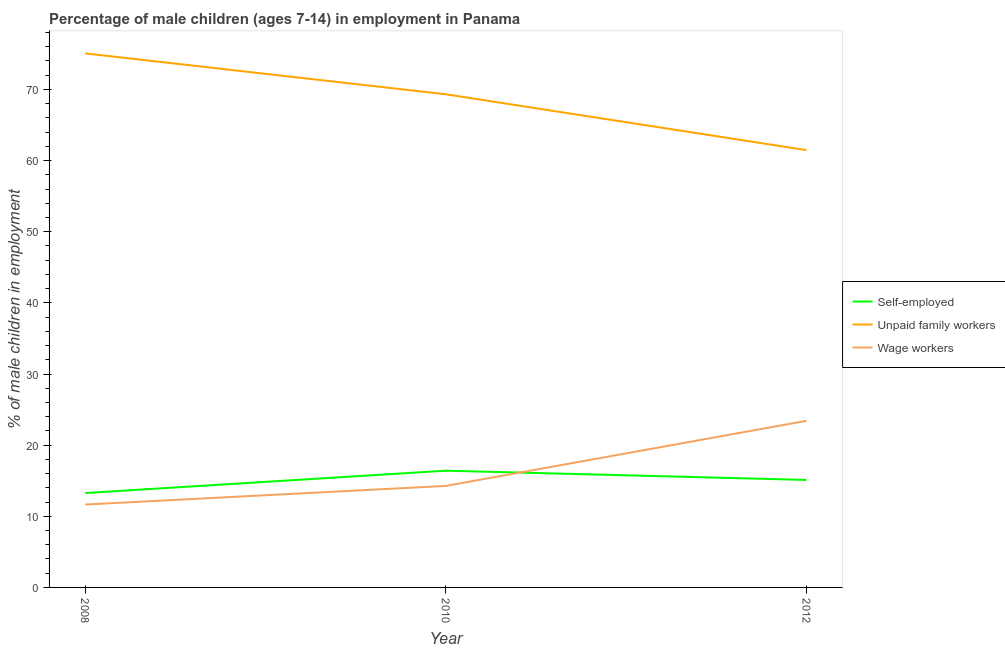Does the line corresponding to percentage of children employed as wage workers intersect with the line corresponding to percentage of self employed children?
Your answer should be compact. Yes. What is the percentage of children employed as unpaid family workers in 2010?
Offer a terse response. 69.32. Across all years, what is the maximum percentage of self employed children?
Your answer should be very brief. 16.41. Across all years, what is the minimum percentage of self employed children?
Your answer should be compact. 13.27. What is the total percentage of self employed children in the graph?
Your answer should be compact. 44.79. What is the difference between the percentage of children employed as unpaid family workers in 2010 and that in 2012?
Make the answer very short. 7.85. What is the difference between the percentage of children employed as wage workers in 2008 and the percentage of children employed as unpaid family workers in 2012?
Your answer should be compact. -49.82. What is the average percentage of children employed as wage workers per year?
Your answer should be compact. 16.45. In the year 2008, what is the difference between the percentage of children employed as unpaid family workers and percentage of self employed children?
Offer a terse response. 61.8. In how many years, is the percentage of children employed as wage workers greater than 18 %?
Offer a very short reply. 1. What is the ratio of the percentage of self employed children in 2010 to that in 2012?
Your response must be concise. 1.09. Is the percentage of self employed children in 2008 less than that in 2010?
Your answer should be compact. Yes. What is the difference between the highest and the second highest percentage of self employed children?
Make the answer very short. 1.3. What is the difference between the highest and the lowest percentage of children employed as wage workers?
Offer a very short reply. 11.77. Does the percentage of children employed as unpaid family workers monotonically increase over the years?
Your answer should be compact. No. Is the percentage of children employed as wage workers strictly greater than the percentage of self employed children over the years?
Provide a short and direct response. No. How many years are there in the graph?
Offer a very short reply. 3. What is the difference between two consecutive major ticks on the Y-axis?
Your answer should be very brief. 10. Does the graph contain any zero values?
Offer a very short reply. No. How many legend labels are there?
Give a very brief answer. 3. How are the legend labels stacked?
Keep it short and to the point. Vertical. What is the title of the graph?
Your answer should be very brief. Percentage of male children (ages 7-14) in employment in Panama. What is the label or title of the Y-axis?
Your response must be concise. % of male children in employment. What is the % of male children in employment in Self-employed in 2008?
Offer a terse response. 13.27. What is the % of male children in employment in Unpaid family workers in 2008?
Give a very brief answer. 75.07. What is the % of male children in employment of Wage workers in 2008?
Offer a terse response. 11.65. What is the % of male children in employment in Self-employed in 2010?
Provide a short and direct response. 16.41. What is the % of male children in employment in Unpaid family workers in 2010?
Provide a short and direct response. 69.32. What is the % of male children in employment of Wage workers in 2010?
Ensure brevity in your answer.  14.27. What is the % of male children in employment of Self-employed in 2012?
Your response must be concise. 15.11. What is the % of male children in employment of Unpaid family workers in 2012?
Provide a succinct answer. 61.47. What is the % of male children in employment of Wage workers in 2012?
Provide a short and direct response. 23.42. Across all years, what is the maximum % of male children in employment of Self-employed?
Offer a terse response. 16.41. Across all years, what is the maximum % of male children in employment of Unpaid family workers?
Keep it short and to the point. 75.07. Across all years, what is the maximum % of male children in employment in Wage workers?
Give a very brief answer. 23.42. Across all years, what is the minimum % of male children in employment in Self-employed?
Your answer should be compact. 13.27. Across all years, what is the minimum % of male children in employment in Unpaid family workers?
Your response must be concise. 61.47. Across all years, what is the minimum % of male children in employment in Wage workers?
Ensure brevity in your answer.  11.65. What is the total % of male children in employment in Self-employed in the graph?
Your response must be concise. 44.79. What is the total % of male children in employment of Unpaid family workers in the graph?
Make the answer very short. 205.86. What is the total % of male children in employment in Wage workers in the graph?
Provide a succinct answer. 49.34. What is the difference between the % of male children in employment of Self-employed in 2008 and that in 2010?
Give a very brief answer. -3.14. What is the difference between the % of male children in employment of Unpaid family workers in 2008 and that in 2010?
Keep it short and to the point. 5.75. What is the difference between the % of male children in employment of Wage workers in 2008 and that in 2010?
Your answer should be compact. -2.62. What is the difference between the % of male children in employment in Self-employed in 2008 and that in 2012?
Offer a very short reply. -1.84. What is the difference between the % of male children in employment of Unpaid family workers in 2008 and that in 2012?
Offer a very short reply. 13.6. What is the difference between the % of male children in employment of Wage workers in 2008 and that in 2012?
Your answer should be very brief. -11.77. What is the difference between the % of male children in employment in Self-employed in 2010 and that in 2012?
Offer a terse response. 1.3. What is the difference between the % of male children in employment of Unpaid family workers in 2010 and that in 2012?
Make the answer very short. 7.85. What is the difference between the % of male children in employment in Wage workers in 2010 and that in 2012?
Keep it short and to the point. -9.15. What is the difference between the % of male children in employment in Self-employed in 2008 and the % of male children in employment in Unpaid family workers in 2010?
Your response must be concise. -56.05. What is the difference between the % of male children in employment in Self-employed in 2008 and the % of male children in employment in Wage workers in 2010?
Offer a terse response. -1. What is the difference between the % of male children in employment of Unpaid family workers in 2008 and the % of male children in employment of Wage workers in 2010?
Provide a succinct answer. 60.8. What is the difference between the % of male children in employment of Self-employed in 2008 and the % of male children in employment of Unpaid family workers in 2012?
Provide a succinct answer. -48.2. What is the difference between the % of male children in employment of Self-employed in 2008 and the % of male children in employment of Wage workers in 2012?
Your response must be concise. -10.15. What is the difference between the % of male children in employment of Unpaid family workers in 2008 and the % of male children in employment of Wage workers in 2012?
Provide a short and direct response. 51.65. What is the difference between the % of male children in employment of Self-employed in 2010 and the % of male children in employment of Unpaid family workers in 2012?
Your answer should be compact. -45.06. What is the difference between the % of male children in employment of Self-employed in 2010 and the % of male children in employment of Wage workers in 2012?
Provide a succinct answer. -7.01. What is the difference between the % of male children in employment in Unpaid family workers in 2010 and the % of male children in employment in Wage workers in 2012?
Ensure brevity in your answer.  45.9. What is the average % of male children in employment of Self-employed per year?
Your response must be concise. 14.93. What is the average % of male children in employment in Unpaid family workers per year?
Your answer should be compact. 68.62. What is the average % of male children in employment in Wage workers per year?
Offer a terse response. 16.45. In the year 2008, what is the difference between the % of male children in employment in Self-employed and % of male children in employment in Unpaid family workers?
Your answer should be very brief. -61.8. In the year 2008, what is the difference between the % of male children in employment in Self-employed and % of male children in employment in Wage workers?
Give a very brief answer. 1.62. In the year 2008, what is the difference between the % of male children in employment of Unpaid family workers and % of male children in employment of Wage workers?
Offer a very short reply. 63.42. In the year 2010, what is the difference between the % of male children in employment in Self-employed and % of male children in employment in Unpaid family workers?
Make the answer very short. -52.91. In the year 2010, what is the difference between the % of male children in employment in Self-employed and % of male children in employment in Wage workers?
Offer a terse response. 2.14. In the year 2010, what is the difference between the % of male children in employment of Unpaid family workers and % of male children in employment of Wage workers?
Your answer should be very brief. 55.05. In the year 2012, what is the difference between the % of male children in employment in Self-employed and % of male children in employment in Unpaid family workers?
Provide a succinct answer. -46.36. In the year 2012, what is the difference between the % of male children in employment of Self-employed and % of male children in employment of Wage workers?
Offer a terse response. -8.31. In the year 2012, what is the difference between the % of male children in employment of Unpaid family workers and % of male children in employment of Wage workers?
Your answer should be very brief. 38.05. What is the ratio of the % of male children in employment in Self-employed in 2008 to that in 2010?
Provide a short and direct response. 0.81. What is the ratio of the % of male children in employment of Unpaid family workers in 2008 to that in 2010?
Your answer should be compact. 1.08. What is the ratio of the % of male children in employment in Wage workers in 2008 to that in 2010?
Keep it short and to the point. 0.82. What is the ratio of the % of male children in employment of Self-employed in 2008 to that in 2012?
Your response must be concise. 0.88. What is the ratio of the % of male children in employment in Unpaid family workers in 2008 to that in 2012?
Keep it short and to the point. 1.22. What is the ratio of the % of male children in employment in Wage workers in 2008 to that in 2012?
Provide a succinct answer. 0.5. What is the ratio of the % of male children in employment of Self-employed in 2010 to that in 2012?
Provide a succinct answer. 1.09. What is the ratio of the % of male children in employment in Unpaid family workers in 2010 to that in 2012?
Keep it short and to the point. 1.13. What is the ratio of the % of male children in employment in Wage workers in 2010 to that in 2012?
Ensure brevity in your answer.  0.61. What is the difference between the highest and the second highest % of male children in employment in Self-employed?
Offer a terse response. 1.3. What is the difference between the highest and the second highest % of male children in employment of Unpaid family workers?
Your response must be concise. 5.75. What is the difference between the highest and the second highest % of male children in employment in Wage workers?
Your response must be concise. 9.15. What is the difference between the highest and the lowest % of male children in employment of Self-employed?
Your response must be concise. 3.14. What is the difference between the highest and the lowest % of male children in employment of Unpaid family workers?
Make the answer very short. 13.6. What is the difference between the highest and the lowest % of male children in employment in Wage workers?
Ensure brevity in your answer.  11.77. 